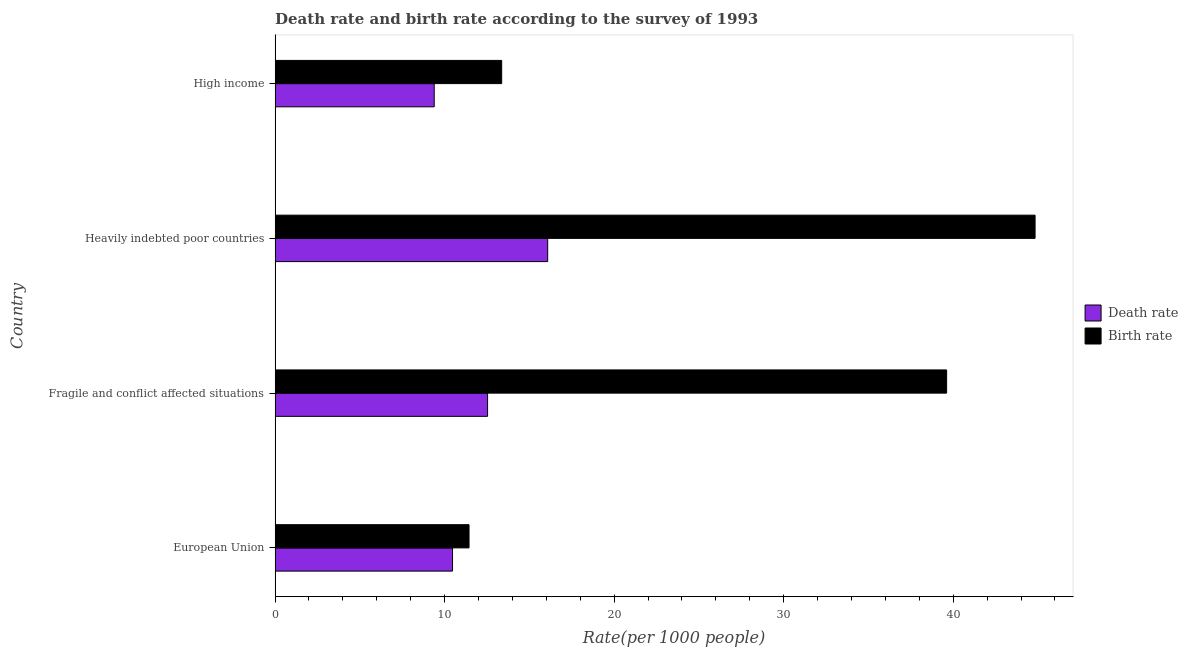How many groups of bars are there?
Offer a terse response. 4. Are the number of bars per tick equal to the number of legend labels?
Your answer should be compact. Yes. Are the number of bars on each tick of the Y-axis equal?
Ensure brevity in your answer.  Yes. How many bars are there on the 3rd tick from the top?
Make the answer very short. 2. How many bars are there on the 1st tick from the bottom?
Your response must be concise. 2. What is the label of the 2nd group of bars from the top?
Provide a short and direct response. Heavily indebted poor countries. What is the birth rate in European Union?
Keep it short and to the point. 11.44. Across all countries, what is the maximum death rate?
Provide a succinct answer. 16.08. Across all countries, what is the minimum birth rate?
Provide a short and direct response. 11.44. In which country was the death rate maximum?
Provide a succinct answer. Heavily indebted poor countries. What is the total birth rate in the graph?
Your response must be concise. 109.24. What is the difference between the birth rate in Fragile and conflict affected situations and that in Heavily indebted poor countries?
Keep it short and to the point. -5.22. What is the difference between the death rate in Heavily indebted poor countries and the birth rate in Fragile and conflict affected situations?
Your answer should be very brief. -23.53. What is the average birth rate per country?
Give a very brief answer. 27.31. What is the difference between the death rate and birth rate in Fragile and conflict affected situations?
Offer a very short reply. -27.07. In how many countries, is the birth rate greater than 34 ?
Your answer should be very brief. 2. What is the ratio of the birth rate in Fragile and conflict affected situations to that in High income?
Give a very brief answer. 2.96. Is the difference between the death rate in European Union and Fragile and conflict affected situations greater than the difference between the birth rate in European Union and Fragile and conflict affected situations?
Your answer should be compact. Yes. What is the difference between the highest and the second highest birth rate?
Provide a short and direct response. 5.22. What is the difference between the highest and the lowest death rate?
Ensure brevity in your answer.  6.69. Is the sum of the death rate in Heavily indebted poor countries and High income greater than the maximum birth rate across all countries?
Your answer should be very brief. No. What does the 1st bar from the top in Heavily indebted poor countries represents?
Your answer should be compact. Birth rate. What does the 1st bar from the bottom in European Union represents?
Make the answer very short. Death rate. Are all the bars in the graph horizontal?
Provide a succinct answer. Yes. Where does the legend appear in the graph?
Your response must be concise. Center right. How many legend labels are there?
Your response must be concise. 2. What is the title of the graph?
Offer a very short reply. Death rate and birth rate according to the survey of 1993. Does "Research and Development" appear as one of the legend labels in the graph?
Offer a very short reply. No. What is the label or title of the X-axis?
Your answer should be compact. Rate(per 1000 people). What is the label or title of the Y-axis?
Your response must be concise. Country. What is the Rate(per 1000 people) of Death rate in European Union?
Your answer should be compact. 10.47. What is the Rate(per 1000 people) of Birth rate in European Union?
Keep it short and to the point. 11.44. What is the Rate(per 1000 people) of Death rate in Fragile and conflict affected situations?
Provide a short and direct response. 12.53. What is the Rate(per 1000 people) in Birth rate in Fragile and conflict affected situations?
Provide a short and direct response. 39.61. What is the Rate(per 1000 people) in Death rate in Heavily indebted poor countries?
Give a very brief answer. 16.08. What is the Rate(per 1000 people) of Birth rate in Heavily indebted poor countries?
Offer a terse response. 44.83. What is the Rate(per 1000 people) in Death rate in High income?
Provide a short and direct response. 9.39. What is the Rate(per 1000 people) in Birth rate in High income?
Offer a terse response. 13.37. Across all countries, what is the maximum Rate(per 1000 people) of Death rate?
Offer a terse response. 16.08. Across all countries, what is the maximum Rate(per 1000 people) in Birth rate?
Give a very brief answer. 44.83. Across all countries, what is the minimum Rate(per 1000 people) in Death rate?
Your answer should be compact. 9.39. Across all countries, what is the minimum Rate(per 1000 people) in Birth rate?
Offer a very short reply. 11.44. What is the total Rate(per 1000 people) of Death rate in the graph?
Your answer should be compact. 48.47. What is the total Rate(per 1000 people) in Birth rate in the graph?
Provide a short and direct response. 109.24. What is the difference between the Rate(per 1000 people) in Death rate in European Union and that in Fragile and conflict affected situations?
Provide a short and direct response. -2.07. What is the difference between the Rate(per 1000 people) in Birth rate in European Union and that in Fragile and conflict affected situations?
Offer a very short reply. -28.17. What is the difference between the Rate(per 1000 people) in Death rate in European Union and that in Heavily indebted poor countries?
Keep it short and to the point. -5.61. What is the difference between the Rate(per 1000 people) in Birth rate in European Union and that in Heavily indebted poor countries?
Make the answer very short. -33.39. What is the difference between the Rate(per 1000 people) in Death rate in European Union and that in High income?
Provide a succinct answer. 1.08. What is the difference between the Rate(per 1000 people) in Birth rate in European Union and that in High income?
Make the answer very short. -1.93. What is the difference between the Rate(per 1000 people) of Death rate in Fragile and conflict affected situations and that in Heavily indebted poor countries?
Your response must be concise. -3.55. What is the difference between the Rate(per 1000 people) in Birth rate in Fragile and conflict affected situations and that in Heavily indebted poor countries?
Provide a succinct answer. -5.22. What is the difference between the Rate(per 1000 people) of Death rate in Fragile and conflict affected situations and that in High income?
Your response must be concise. 3.15. What is the difference between the Rate(per 1000 people) of Birth rate in Fragile and conflict affected situations and that in High income?
Provide a succinct answer. 26.24. What is the difference between the Rate(per 1000 people) of Death rate in Heavily indebted poor countries and that in High income?
Offer a very short reply. 6.69. What is the difference between the Rate(per 1000 people) of Birth rate in Heavily indebted poor countries and that in High income?
Provide a succinct answer. 31.46. What is the difference between the Rate(per 1000 people) in Death rate in European Union and the Rate(per 1000 people) in Birth rate in Fragile and conflict affected situations?
Offer a very short reply. -29.14. What is the difference between the Rate(per 1000 people) in Death rate in European Union and the Rate(per 1000 people) in Birth rate in Heavily indebted poor countries?
Your answer should be very brief. -34.36. What is the difference between the Rate(per 1000 people) in Death rate in European Union and the Rate(per 1000 people) in Birth rate in High income?
Provide a short and direct response. -2.9. What is the difference between the Rate(per 1000 people) in Death rate in Fragile and conflict affected situations and the Rate(per 1000 people) in Birth rate in Heavily indebted poor countries?
Make the answer very short. -32.29. What is the difference between the Rate(per 1000 people) of Death rate in Fragile and conflict affected situations and the Rate(per 1000 people) of Birth rate in High income?
Provide a short and direct response. -0.83. What is the difference between the Rate(per 1000 people) of Death rate in Heavily indebted poor countries and the Rate(per 1000 people) of Birth rate in High income?
Provide a succinct answer. 2.71. What is the average Rate(per 1000 people) in Death rate per country?
Make the answer very short. 12.12. What is the average Rate(per 1000 people) in Birth rate per country?
Your answer should be compact. 27.31. What is the difference between the Rate(per 1000 people) of Death rate and Rate(per 1000 people) of Birth rate in European Union?
Give a very brief answer. -0.97. What is the difference between the Rate(per 1000 people) in Death rate and Rate(per 1000 people) in Birth rate in Fragile and conflict affected situations?
Your answer should be compact. -27.08. What is the difference between the Rate(per 1000 people) of Death rate and Rate(per 1000 people) of Birth rate in Heavily indebted poor countries?
Offer a very short reply. -28.75. What is the difference between the Rate(per 1000 people) in Death rate and Rate(per 1000 people) in Birth rate in High income?
Ensure brevity in your answer.  -3.98. What is the ratio of the Rate(per 1000 people) of Death rate in European Union to that in Fragile and conflict affected situations?
Provide a succinct answer. 0.83. What is the ratio of the Rate(per 1000 people) of Birth rate in European Union to that in Fragile and conflict affected situations?
Your answer should be very brief. 0.29. What is the ratio of the Rate(per 1000 people) in Death rate in European Union to that in Heavily indebted poor countries?
Ensure brevity in your answer.  0.65. What is the ratio of the Rate(per 1000 people) in Birth rate in European Union to that in Heavily indebted poor countries?
Provide a succinct answer. 0.26. What is the ratio of the Rate(per 1000 people) of Death rate in European Union to that in High income?
Your response must be concise. 1.11. What is the ratio of the Rate(per 1000 people) of Birth rate in European Union to that in High income?
Offer a terse response. 0.86. What is the ratio of the Rate(per 1000 people) of Death rate in Fragile and conflict affected situations to that in Heavily indebted poor countries?
Your response must be concise. 0.78. What is the ratio of the Rate(per 1000 people) of Birth rate in Fragile and conflict affected situations to that in Heavily indebted poor countries?
Provide a succinct answer. 0.88. What is the ratio of the Rate(per 1000 people) in Death rate in Fragile and conflict affected situations to that in High income?
Your response must be concise. 1.34. What is the ratio of the Rate(per 1000 people) of Birth rate in Fragile and conflict affected situations to that in High income?
Your answer should be compact. 2.96. What is the ratio of the Rate(per 1000 people) in Death rate in Heavily indebted poor countries to that in High income?
Provide a succinct answer. 1.71. What is the ratio of the Rate(per 1000 people) in Birth rate in Heavily indebted poor countries to that in High income?
Your response must be concise. 3.35. What is the difference between the highest and the second highest Rate(per 1000 people) of Death rate?
Offer a very short reply. 3.55. What is the difference between the highest and the second highest Rate(per 1000 people) in Birth rate?
Your answer should be very brief. 5.22. What is the difference between the highest and the lowest Rate(per 1000 people) of Death rate?
Make the answer very short. 6.69. What is the difference between the highest and the lowest Rate(per 1000 people) in Birth rate?
Give a very brief answer. 33.39. 